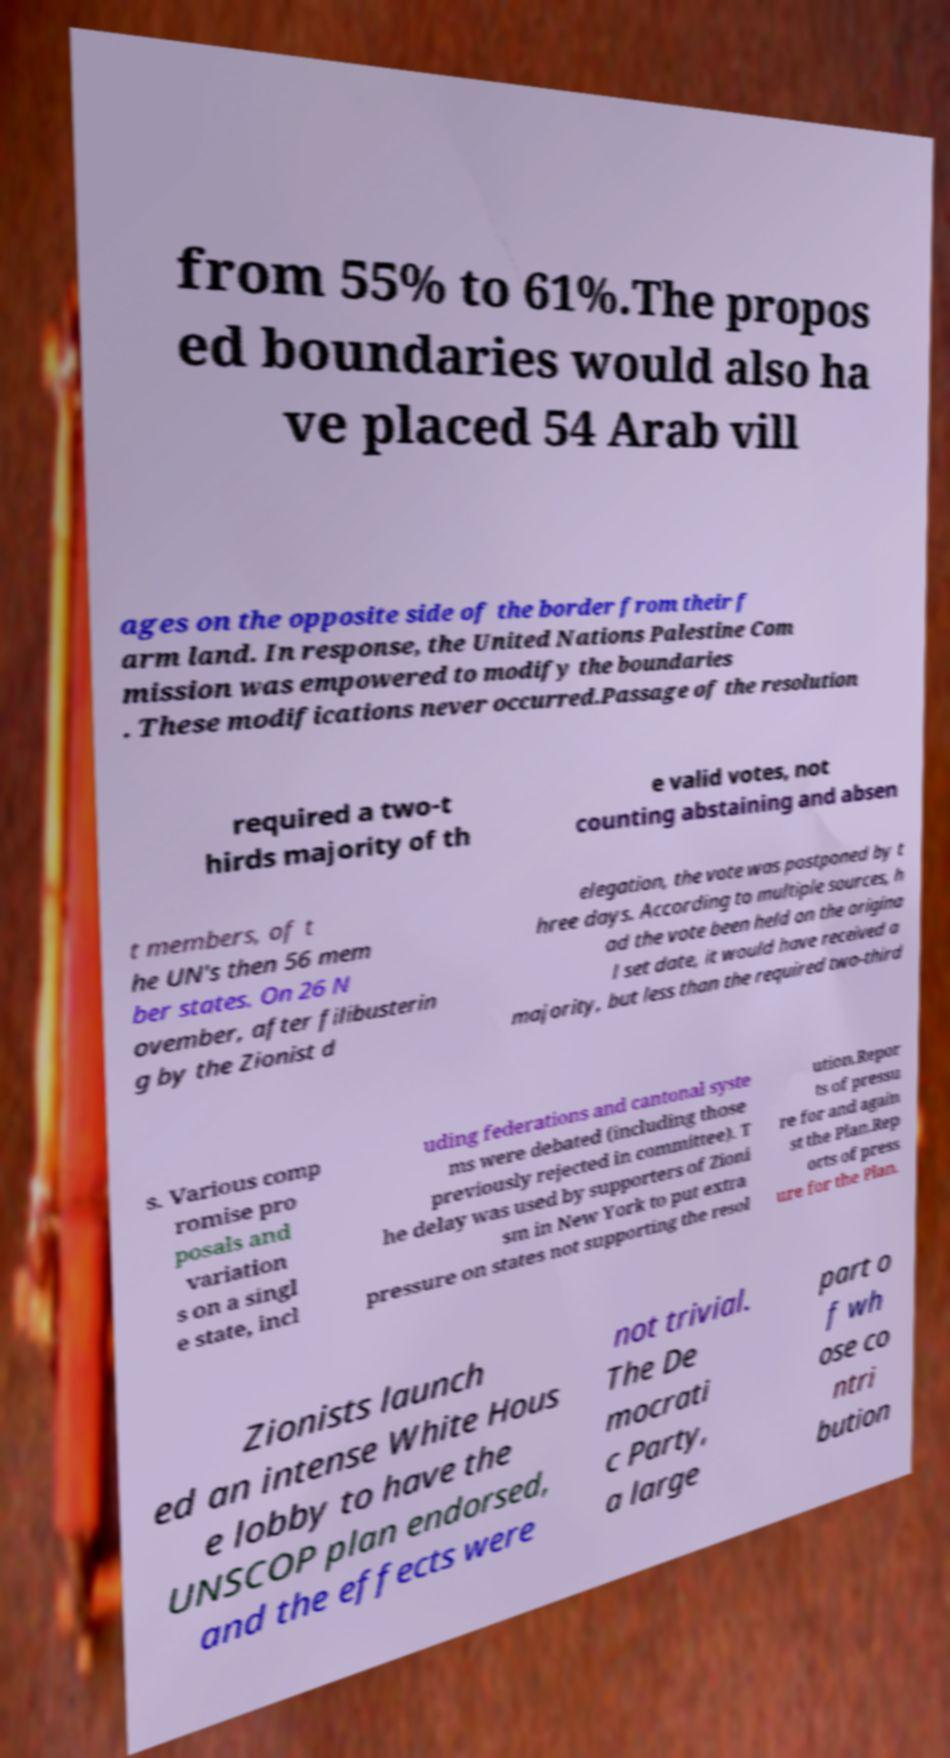There's text embedded in this image that I need extracted. Can you transcribe it verbatim? from 55% to 61%.The propos ed boundaries would also ha ve placed 54 Arab vill ages on the opposite side of the border from their f arm land. In response, the United Nations Palestine Com mission was empowered to modify the boundaries . These modifications never occurred.Passage of the resolution required a two-t hirds majority of th e valid votes, not counting abstaining and absen t members, of t he UN's then 56 mem ber states. On 26 N ovember, after filibusterin g by the Zionist d elegation, the vote was postponed by t hree days. According to multiple sources, h ad the vote been held on the origina l set date, it would have received a majority, but less than the required two-third s. Various comp romise pro posals and variation s on a singl e state, incl uding federations and cantonal syste ms were debated (including those previously rejected in committee). T he delay was used by supporters of Zioni sm in New York to put extra pressure on states not supporting the resol ution.Repor ts of pressu re for and again st the Plan.Rep orts of press ure for the Plan. Zionists launch ed an intense White Hous e lobby to have the UNSCOP plan endorsed, and the effects were not trivial. The De mocrati c Party, a large part o f wh ose co ntri bution 